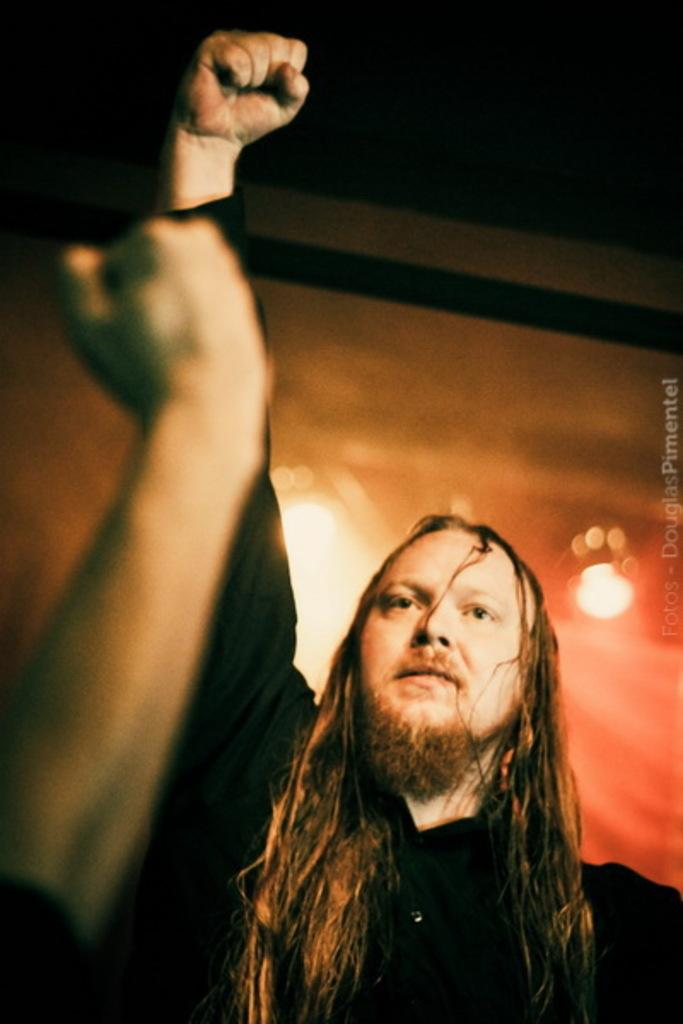Who is the main subject in the image? There is a man in the image. Where is the man positioned in the image? The man is standing in the center of the image. What is the man doing in the image? The man is raising his hand. What type of toy is the man playing with in the image? There is no toy present in the image; the man is simply raising his hand. Can you describe the man's eye color in the image? The provided facts do not mention the man's eye color, so it cannot be determined from the image. 